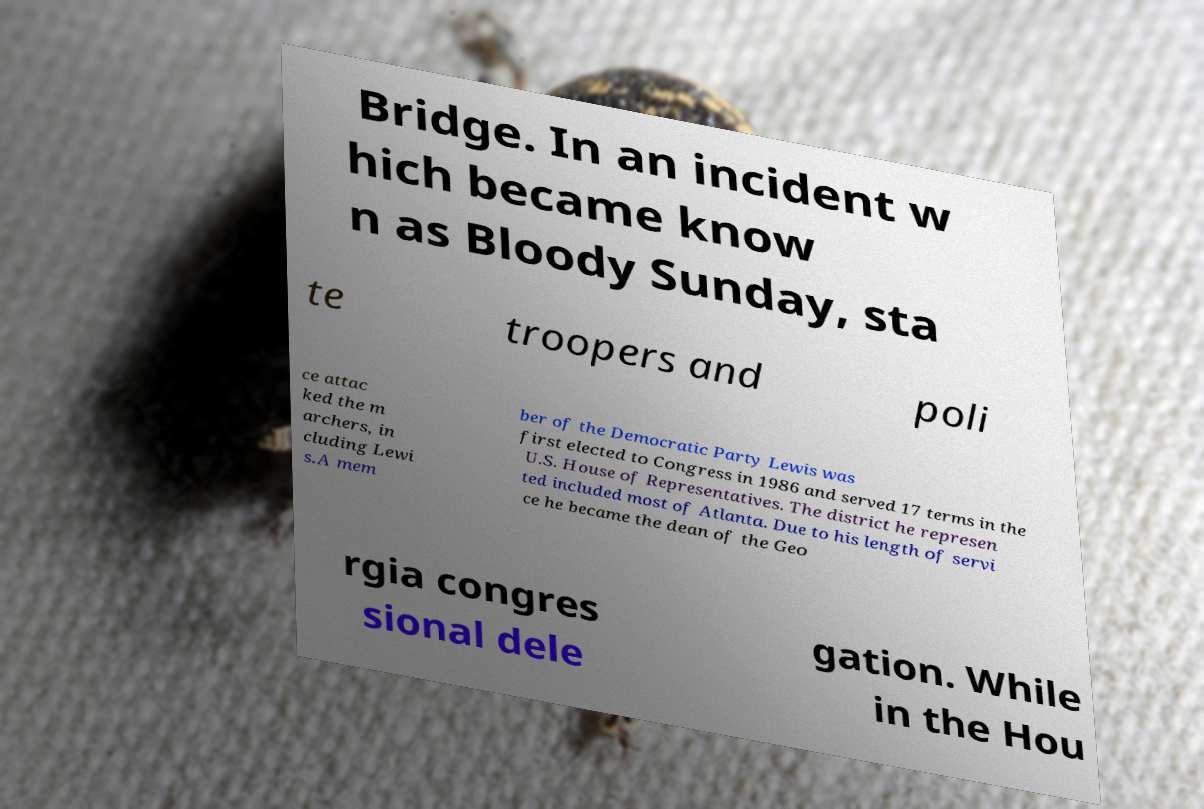Could you assist in decoding the text presented in this image and type it out clearly? Bridge. In an incident w hich became know n as Bloody Sunday, sta te troopers and poli ce attac ked the m archers, in cluding Lewi s.A mem ber of the Democratic Party Lewis was first elected to Congress in 1986 and served 17 terms in the U.S. House of Representatives. The district he represen ted included most of Atlanta. Due to his length of servi ce he became the dean of the Geo rgia congres sional dele gation. While in the Hou 